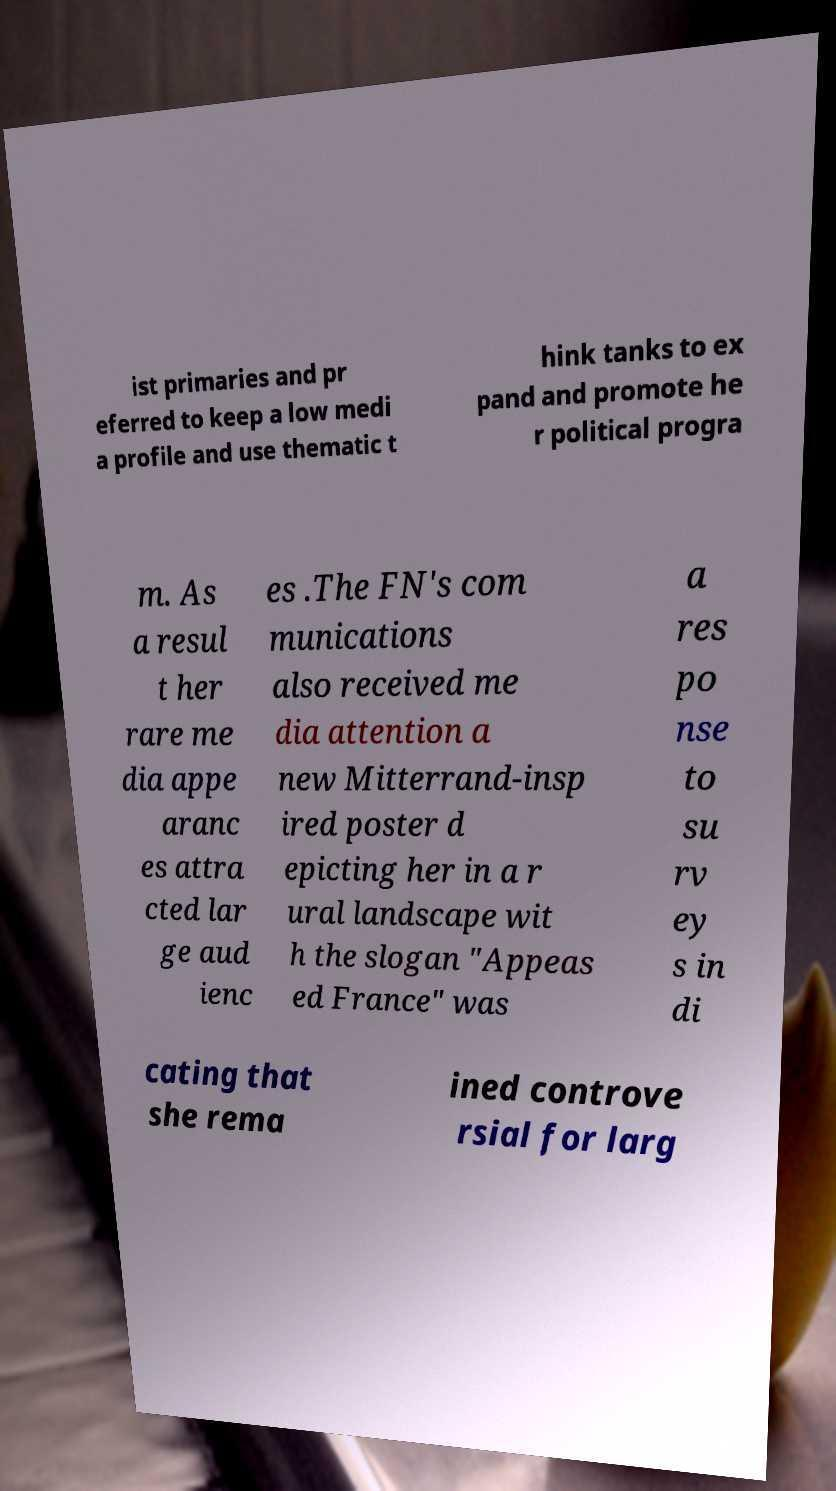Can you read and provide the text displayed in the image?This photo seems to have some interesting text. Can you extract and type it out for me? ist primaries and pr eferred to keep a low medi a profile and use thematic t hink tanks to ex pand and promote he r political progra m. As a resul t her rare me dia appe aranc es attra cted lar ge aud ienc es .The FN's com munications also received me dia attention a new Mitterrand-insp ired poster d epicting her in a r ural landscape wit h the slogan "Appeas ed France" was a res po nse to su rv ey s in di cating that she rema ined controve rsial for larg 